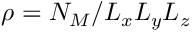<formula> <loc_0><loc_0><loc_500><loc_500>\rho = N _ { M } / L _ { x } L _ { y } L _ { z }</formula> 